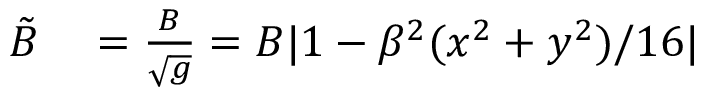Convert formula to latex. <formula><loc_0><loc_0><loc_500><loc_500>\begin{array} { r l } { \tilde { B } } & = \frac { B } { \sqrt { g } } = B | 1 - \beta ^ { 2 } ( x ^ { 2 } + y ^ { 2 } ) / 1 6 | } \end{array}</formula> 